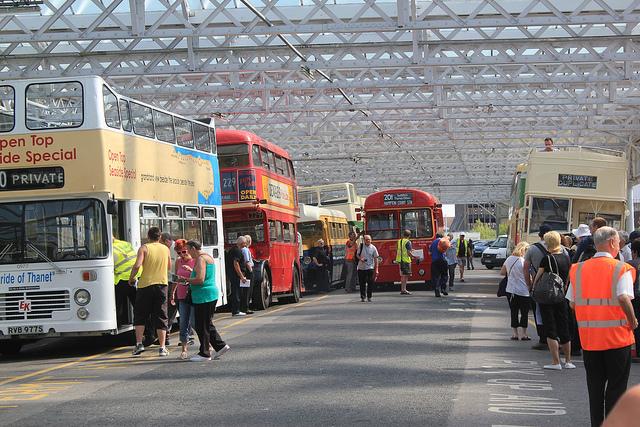Why does the man on the right have an orange vest?
Write a very short answer. Yes. What kind of weather it is?
Give a very brief answer. Sunny. How does the first bus on the left differ from the second bus on the left?
Keep it brief. Color. Is there a school bus in the photo?
Short answer required. Yes. What station is he near?
Write a very short answer. Bus. Why are they waiting?
Quick response, please. For bus. What is the man carrying on his back?
Concise answer only. Bag. What color is the worker's vest?
Write a very short answer. Orange. 